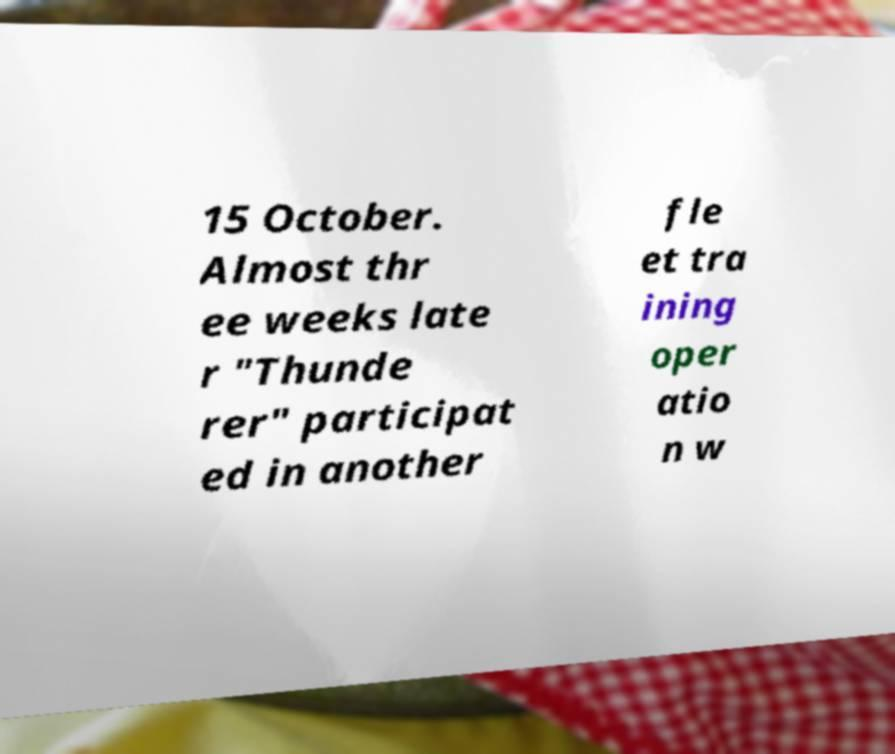What messages or text are displayed in this image? I need them in a readable, typed format. 15 October. Almost thr ee weeks late r "Thunde rer" participat ed in another fle et tra ining oper atio n w 